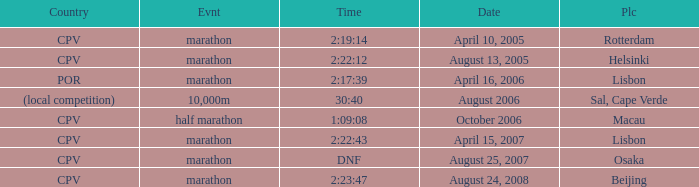What is the Event labeled Country of (local competition)? 10,000m. 